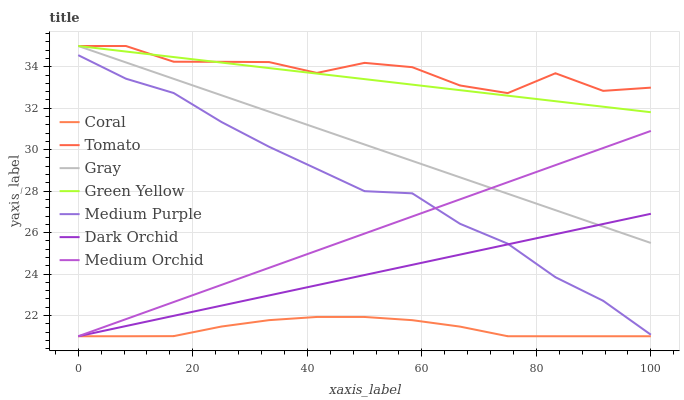Does Coral have the minimum area under the curve?
Answer yes or no. Yes. Does Tomato have the maximum area under the curve?
Answer yes or no. Yes. Does Gray have the minimum area under the curve?
Answer yes or no. No. Does Gray have the maximum area under the curve?
Answer yes or no. No. Is Gray the smoothest?
Answer yes or no. Yes. Is Tomato the roughest?
Answer yes or no. Yes. Is Coral the smoothest?
Answer yes or no. No. Is Coral the roughest?
Answer yes or no. No. Does Coral have the lowest value?
Answer yes or no. Yes. Does Gray have the lowest value?
Answer yes or no. No. Does Green Yellow have the highest value?
Answer yes or no. Yes. Does Coral have the highest value?
Answer yes or no. No. Is Medium Purple less than Green Yellow?
Answer yes or no. Yes. Is Green Yellow greater than Coral?
Answer yes or no. Yes. Does Coral intersect Dark Orchid?
Answer yes or no. Yes. Is Coral less than Dark Orchid?
Answer yes or no. No. Is Coral greater than Dark Orchid?
Answer yes or no. No. Does Medium Purple intersect Green Yellow?
Answer yes or no. No. 